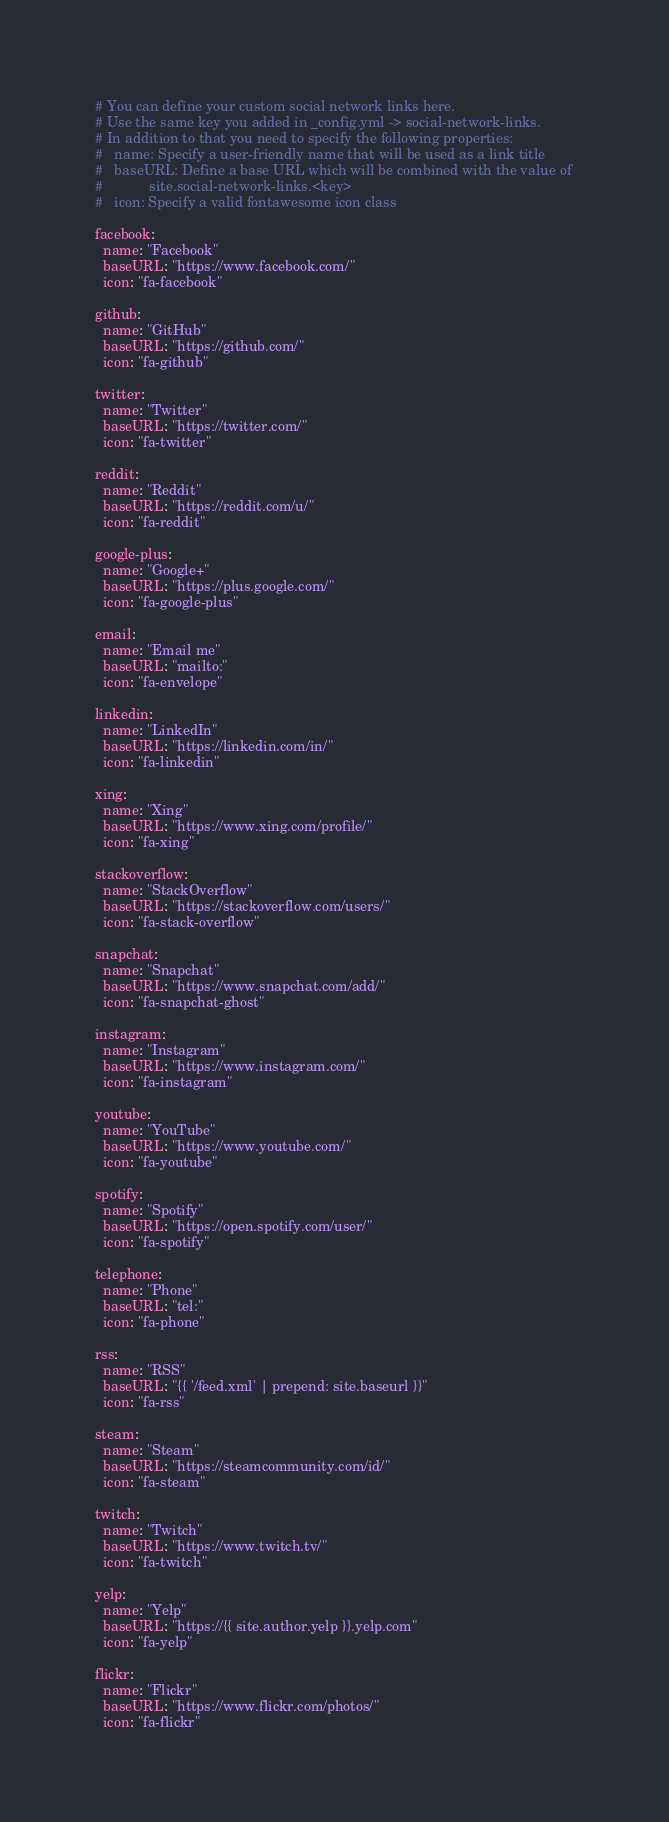<code> <loc_0><loc_0><loc_500><loc_500><_YAML_># You can define your custom social network links here.
# Use the same key you added in _config.yml -> social-network-links.
# In addition to that you need to specify the following properties:
#   name: Specify a user-friendly name that will be used as a link title
#   baseURL: Define a base URL which will be combined with the value of
#            site.social-network-links.<key>
#   icon: Specify a valid fontawesome icon class

facebook:
  name: "Facebook"
  baseURL: "https://www.facebook.com/"
  icon: "fa-facebook"

github:
  name: "GitHub"
  baseURL: "https://github.com/"
  icon: "fa-github"

twitter:
  name: "Twitter"
  baseURL: "https://twitter.com/"
  icon: "fa-twitter"

reddit:
  name: "Reddit"
  baseURL: "https://reddit.com/u/"
  icon: "fa-reddit"

google-plus:
  name: "Google+"
  baseURL: "https://plus.google.com/"
  icon: "fa-google-plus"

email:
  name: "Email me"
  baseURL: "mailto:"
  icon: "fa-envelope"

linkedin:
  name: "LinkedIn"
  baseURL: "https://linkedin.com/in/"
  icon: "fa-linkedin"

xing:
  name: "Xing"
  baseURL: "https://www.xing.com/profile/"
  icon: "fa-xing"

stackoverflow:
  name: "StackOverflow"
  baseURL: "https://stackoverflow.com/users/"
  icon: "fa-stack-overflow"

snapchat:
  name: "Snapchat"
  baseURL: "https://www.snapchat.com/add/"
  icon: "fa-snapchat-ghost"

instagram:
  name: "Instagram"
  baseURL: "https://www.instagram.com/"
  icon: "fa-instagram"

youtube:
  name: "YouTube"
  baseURL: "https://www.youtube.com/"
  icon: "fa-youtube"

spotify:
  name: "Spotify"
  baseURL: "https://open.spotify.com/user/"
  icon: "fa-spotify"

telephone:
  name: "Phone"
  baseURL: "tel:"
  icon: "fa-phone"

rss:
  name: "RSS"
  baseURL: "{{ '/feed.xml' | prepend: site.baseurl }}"
  icon: "fa-rss"

steam:
  name: "Steam"
  baseURL: "https://steamcommunity.com/id/"
  icon: "fa-steam"

twitch:
  name: "Twitch"
  baseURL: "https://www.twitch.tv/"
  icon: "fa-twitch"

yelp:
  name: "Yelp"
  baseURL: "https://{{ site.author.yelp }}.yelp.com"
  icon: "fa-yelp"

flickr:
  name: "Flickr"
  baseURL: "https://www.flickr.com/photos/"
  icon: "fa-flickr"
</code> 